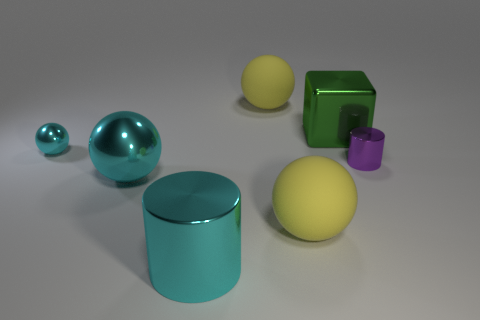Subtract all big cyan spheres. How many spheres are left? 3 Subtract all blue cylinders. How many yellow balls are left? 2 Add 3 large green metal blocks. How many objects exist? 10 Subtract all cylinders. How many objects are left? 5 Subtract 0 blue spheres. How many objects are left? 7 Subtract all brown cylinders. Subtract all purple spheres. How many cylinders are left? 2 Subtract all large green metallic blocks. Subtract all spheres. How many objects are left? 2 Add 3 big blocks. How many big blocks are left? 4 Add 1 green metal objects. How many green metal objects exist? 2 